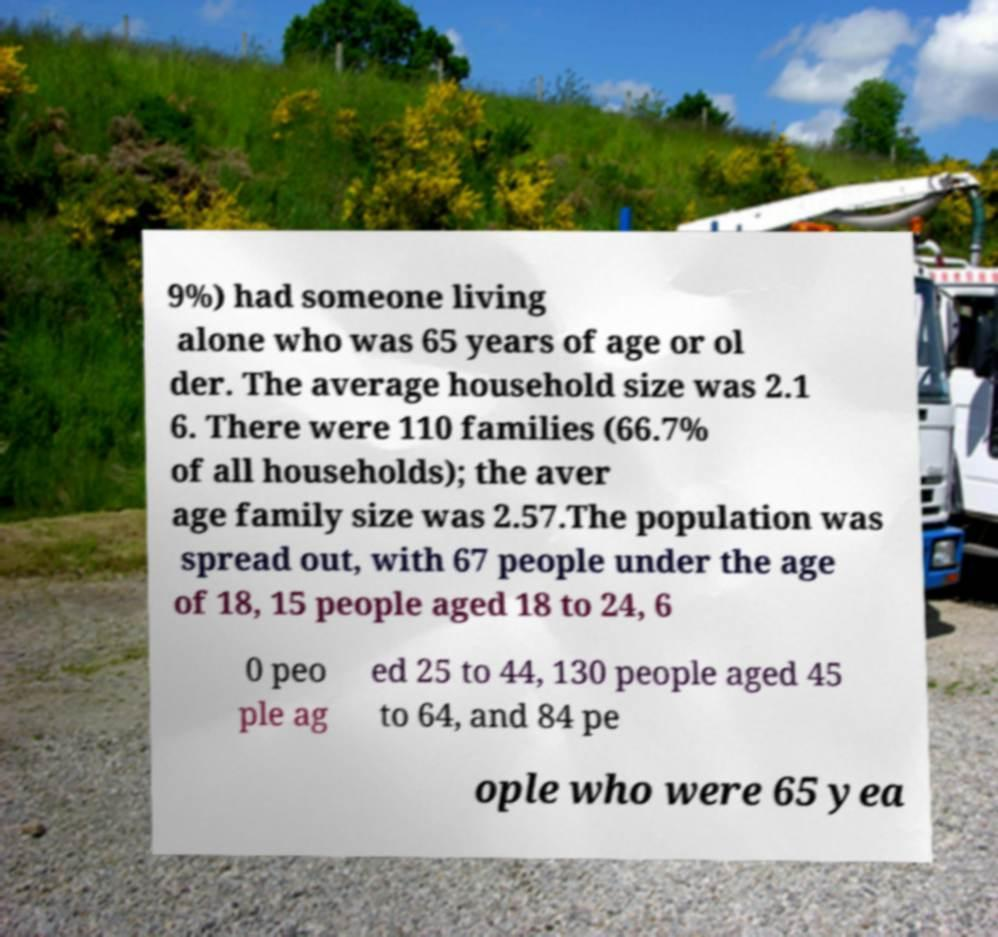Can you read and provide the text displayed in the image?This photo seems to have some interesting text. Can you extract and type it out for me? 9%) had someone living alone who was 65 years of age or ol der. The average household size was 2.1 6. There were 110 families (66.7% of all households); the aver age family size was 2.57.The population was spread out, with 67 people under the age of 18, 15 people aged 18 to 24, 6 0 peo ple ag ed 25 to 44, 130 people aged 45 to 64, and 84 pe ople who were 65 yea 